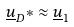<formula> <loc_0><loc_0><loc_500><loc_500>\underline { u } _ { D } * \approx \underline { u } _ { 1 }</formula> 